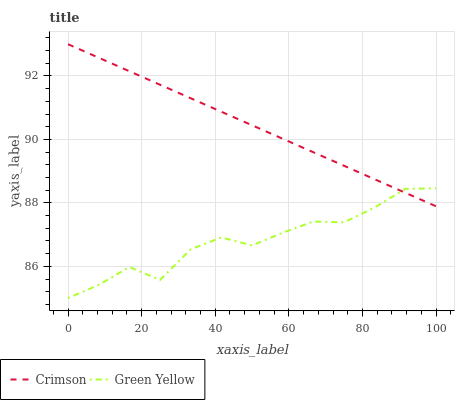Does Green Yellow have the maximum area under the curve?
Answer yes or no. No. Is Green Yellow the smoothest?
Answer yes or no. No. Does Green Yellow have the highest value?
Answer yes or no. No. 